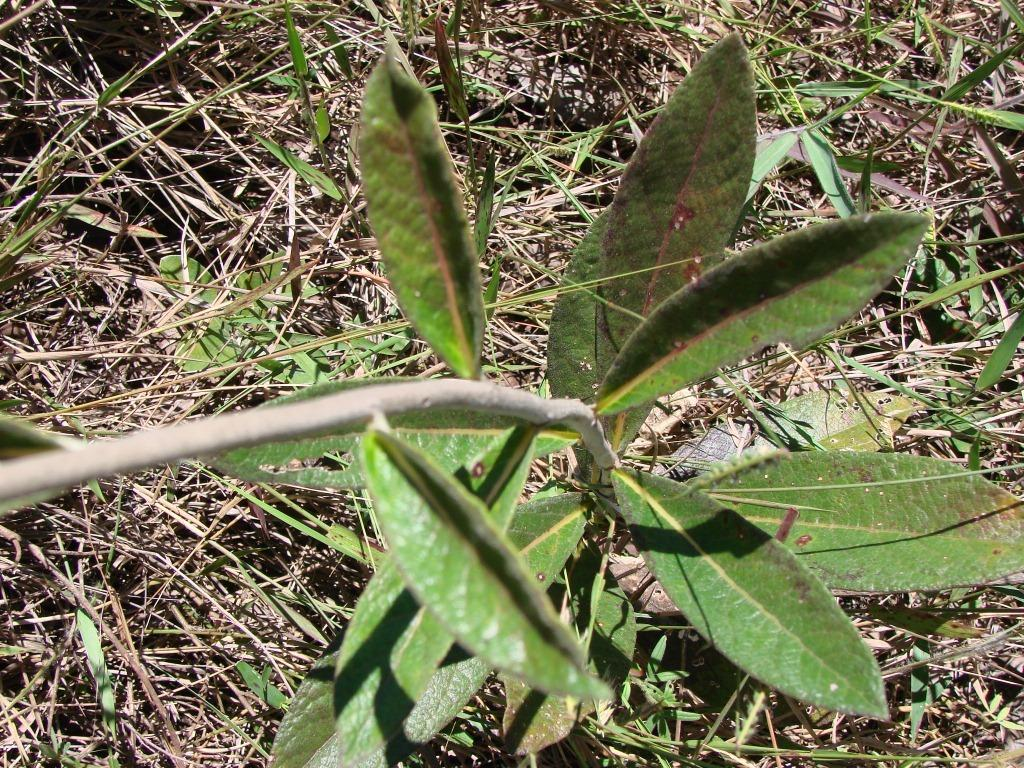What is the main subject of the image? The main subject of the image is a plant stem. What features can be observed on the plant stem? The plant stem has leaves. What type of vegetation is present on the ground in the image? There is dried grass on the ground in the image. How many sisters are depicted in the advertisement in the image? There is no advertisement or sisters present in the image; it features a plant stem with leaves and dried grass on the ground. 